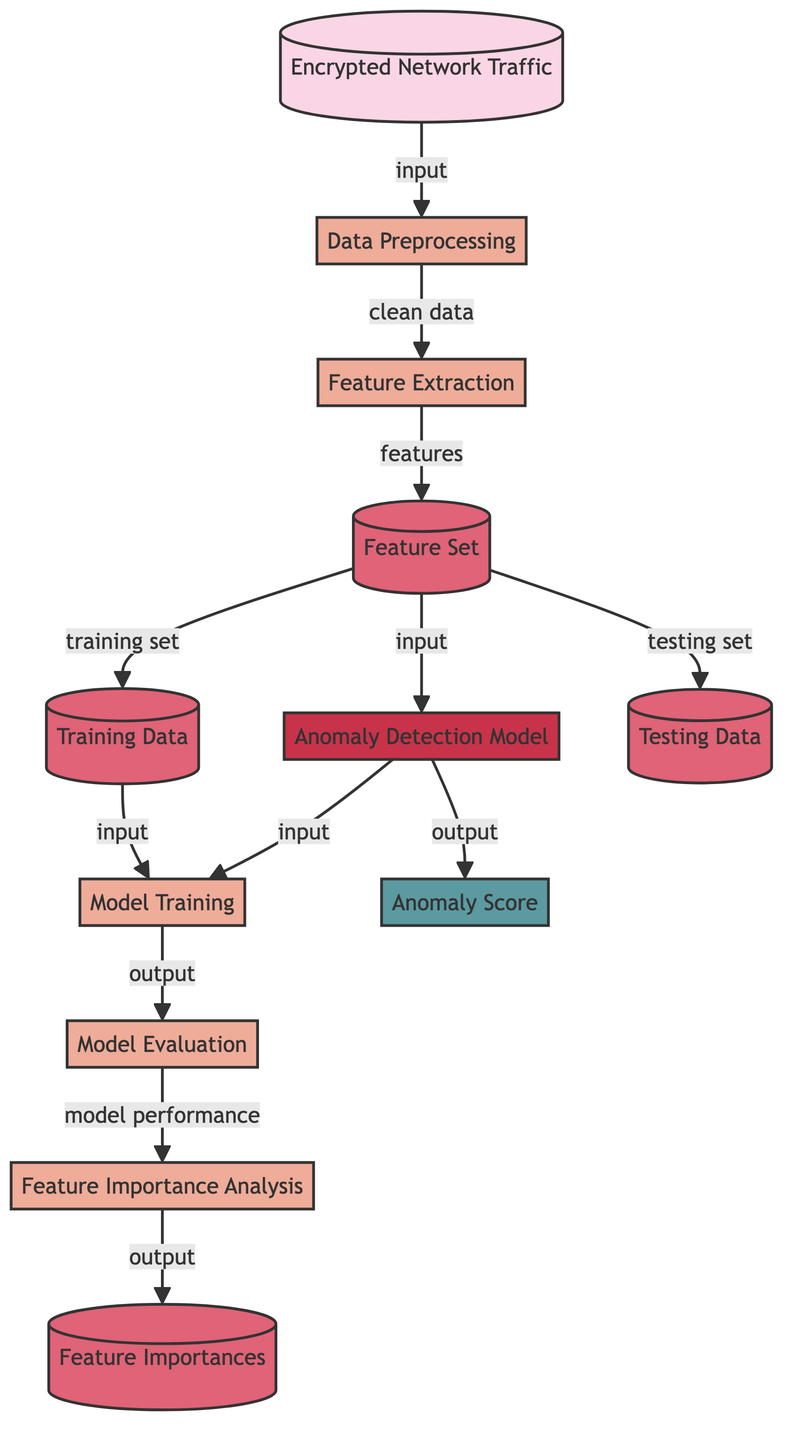What is the first step in the process? The diagram shows that the first node is "Encrypted Network Traffic," which is the starting point of the flow, indicating it is the input into the system.
Answer: Encrypted Network Traffic How many processes are shown in the diagram? The diagram features three processes: "Data Preprocessing," "Feature Extraction," and "Model Training," which are key steps in the machine learning workflow.
Answer: Three What is the output of the anomaly detection model? The final output of the "Anomaly Detection Model" is represented by the node labeled "Anomaly Score," which indicates the result of the model's operation.
Answer: Anomaly Score Which node directly follows "Feature Set"? The diagram indicates that "Feature Set" directly leads to the node "Anomaly Detection Model," which means the feature set is used as input for the model.
Answer: Anomaly Detection Model What type of data is used for training the model? According to the diagram, the training data is indicated as "Training Data," which is derived from the "Feature Set" before the training process begins.
Answer: Training Data What analysis follows model evaluation? The "Model Evaluation" step directly leads to "Feature Importance Analysis," suggesting that an analysis of feature importance occurs after evaluating the model's performance.
Answer: Feature Importance Analysis What is the classification for "Model Training"? In the diagram, the node "Model Training" is classified under the process category, indicating it is an essential part of the workflow for developing the anomaly detection model.
Answer: Process Which data node provides input to the model training? The "Training Data" node, shown as a data input, is specifically used to guide the model training process alongside the "Anomaly Detection Model."
Answer: Training Data 